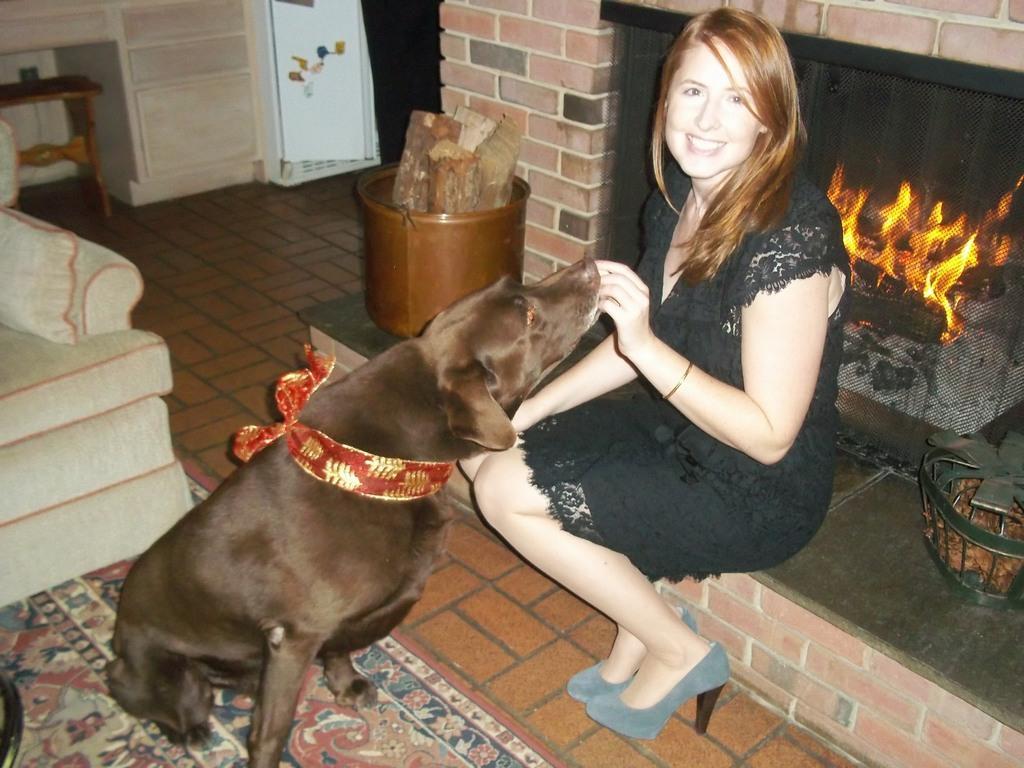Can you describe this image briefly? In this image there is a dog with a woman beside her, the woman is having a smile on her face, in front of the woman there is a sofa bed, behind the woman there is a fireplace. 